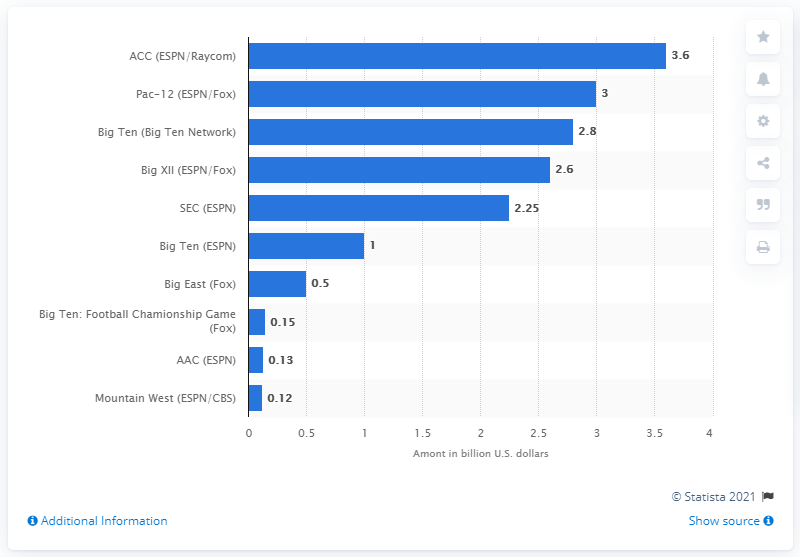Specify some key components in this picture. The amount that ESPN and Raycom paid to cover the Atlantic Coast Conference is 3.6. 